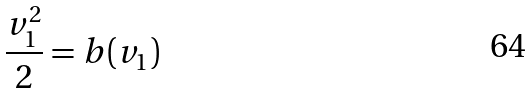Convert formula to latex. <formula><loc_0><loc_0><loc_500><loc_500>\frac { v _ { 1 } ^ { 2 } } { 2 } = b ( v _ { 1 } )</formula> 